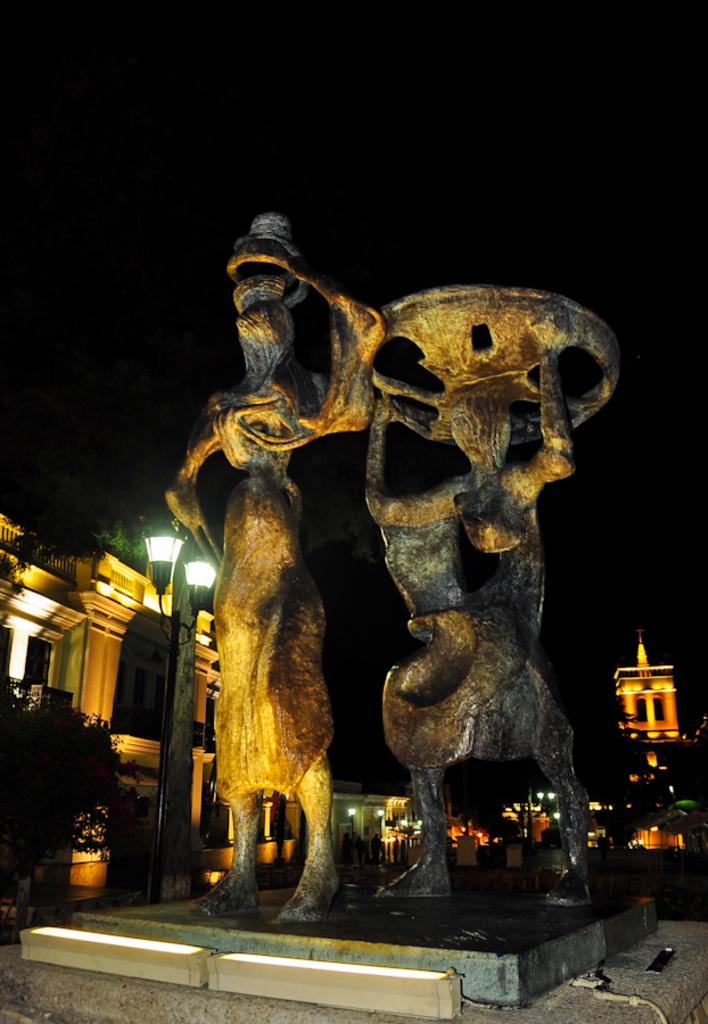What time of day was the image taken? The image was taken at night. What can be seen in the middle of the image? There are two statues in the middle of the image. What is visible in the background of the image? There are buildings with many lights in the background. What type of vegetation is present in front of the buildings in the background? Trees are present in front of the buildings in the background. What type of calendar is hanging on the wall behind the statues in the image? There is no calendar visible in the image; it only features two statues and the background with buildings and trees. 